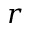Convert formula to latex. <formula><loc_0><loc_0><loc_500><loc_500>r</formula> 